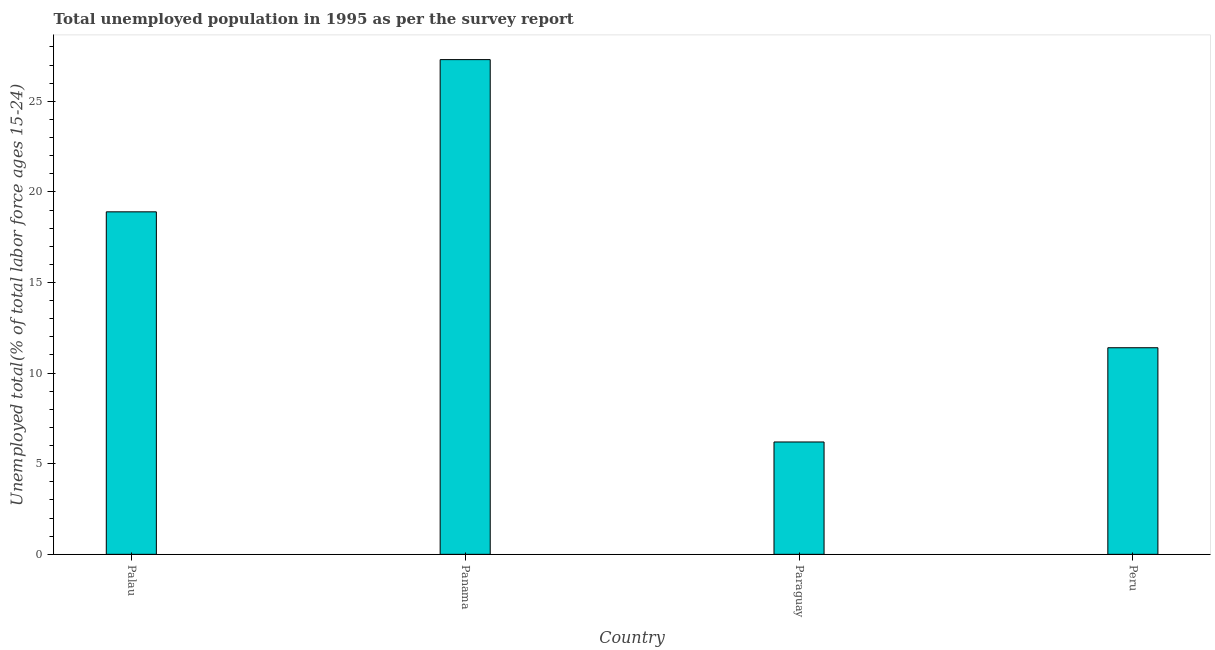Does the graph contain any zero values?
Provide a short and direct response. No. What is the title of the graph?
Keep it short and to the point. Total unemployed population in 1995 as per the survey report. What is the label or title of the X-axis?
Your answer should be very brief. Country. What is the label or title of the Y-axis?
Ensure brevity in your answer.  Unemployed total(% of total labor force ages 15-24). What is the unemployed youth in Panama?
Keep it short and to the point. 27.3. Across all countries, what is the maximum unemployed youth?
Keep it short and to the point. 27.3. Across all countries, what is the minimum unemployed youth?
Your answer should be very brief. 6.2. In which country was the unemployed youth maximum?
Make the answer very short. Panama. In which country was the unemployed youth minimum?
Offer a very short reply. Paraguay. What is the sum of the unemployed youth?
Keep it short and to the point. 63.8. What is the average unemployed youth per country?
Provide a short and direct response. 15.95. What is the median unemployed youth?
Give a very brief answer. 15.15. In how many countries, is the unemployed youth greater than 2 %?
Provide a succinct answer. 4. What is the ratio of the unemployed youth in Panama to that in Peru?
Your response must be concise. 2.4. Is the unemployed youth in Palau less than that in Panama?
Give a very brief answer. Yes. Is the difference between the unemployed youth in Palau and Peru greater than the difference between any two countries?
Give a very brief answer. No. What is the difference between the highest and the lowest unemployed youth?
Make the answer very short. 21.1. In how many countries, is the unemployed youth greater than the average unemployed youth taken over all countries?
Keep it short and to the point. 2. Are all the bars in the graph horizontal?
Make the answer very short. No. What is the difference between two consecutive major ticks on the Y-axis?
Your response must be concise. 5. Are the values on the major ticks of Y-axis written in scientific E-notation?
Make the answer very short. No. What is the Unemployed total(% of total labor force ages 15-24) in Palau?
Your answer should be very brief. 18.9. What is the Unemployed total(% of total labor force ages 15-24) in Panama?
Give a very brief answer. 27.3. What is the Unemployed total(% of total labor force ages 15-24) of Paraguay?
Your answer should be compact. 6.2. What is the Unemployed total(% of total labor force ages 15-24) in Peru?
Your response must be concise. 11.4. What is the difference between the Unemployed total(% of total labor force ages 15-24) in Panama and Paraguay?
Your answer should be compact. 21.1. What is the difference between the Unemployed total(% of total labor force ages 15-24) in Paraguay and Peru?
Provide a succinct answer. -5.2. What is the ratio of the Unemployed total(% of total labor force ages 15-24) in Palau to that in Panama?
Keep it short and to the point. 0.69. What is the ratio of the Unemployed total(% of total labor force ages 15-24) in Palau to that in Paraguay?
Make the answer very short. 3.05. What is the ratio of the Unemployed total(% of total labor force ages 15-24) in Palau to that in Peru?
Your answer should be very brief. 1.66. What is the ratio of the Unemployed total(% of total labor force ages 15-24) in Panama to that in Paraguay?
Your response must be concise. 4.4. What is the ratio of the Unemployed total(% of total labor force ages 15-24) in Panama to that in Peru?
Your answer should be very brief. 2.4. What is the ratio of the Unemployed total(% of total labor force ages 15-24) in Paraguay to that in Peru?
Make the answer very short. 0.54. 